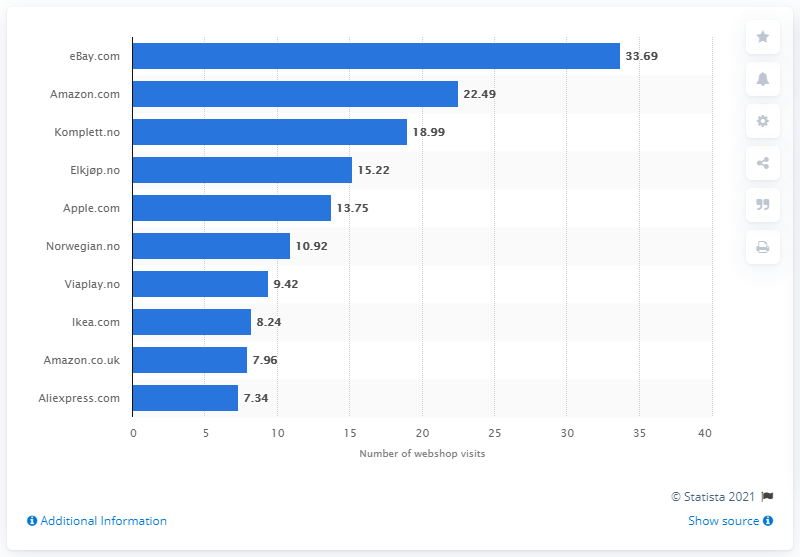List a handful of essential elements in this visual. According to data, Aliexpress.com ranked last out of the top ten webshops with approximately 7.3 million visits during a six-month period. During a six month period, Aliexpress.com received a total of 7,340 visits. 